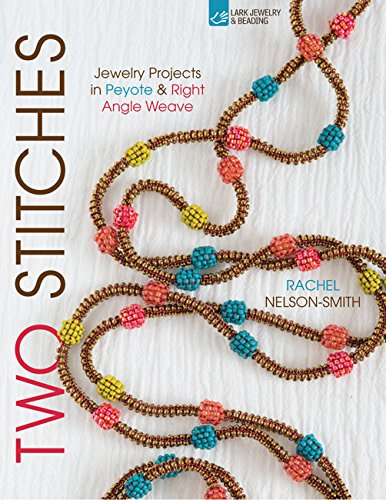Is this book related to Crafts, Hobbies & Home? Yes, this book is thoroughly related to 'Crafts, Hobbies & Home', as it offers practical projects and insights into the art of bead weaving. 